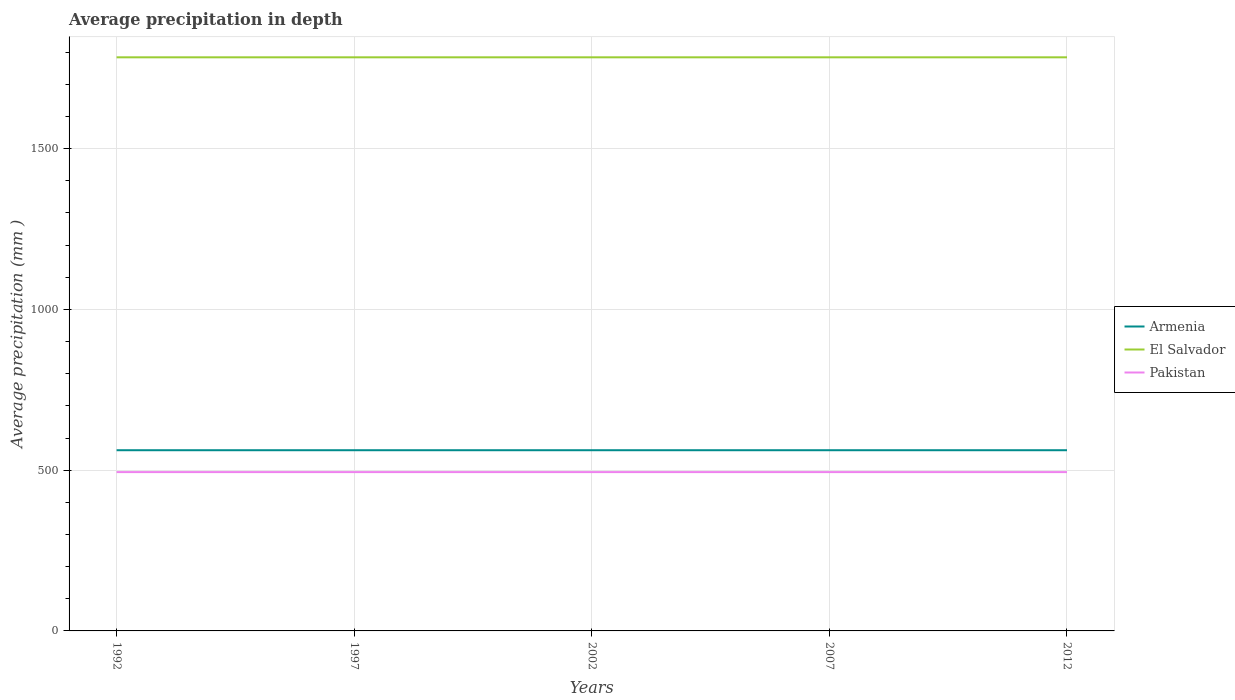How many different coloured lines are there?
Offer a very short reply. 3. Is the number of lines equal to the number of legend labels?
Offer a very short reply. Yes. Across all years, what is the maximum average precipitation in Armenia?
Offer a terse response. 562. In which year was the average precipitation in Pakistan maximum?
Keep it short and to the point. 1992. What is the total average precipitation in Pakistan in the graph?
Make the answer very short. 0. What is the difference between the highest and the second highest average precipitation in Armenia?
Your response must be concise. 0. What is the difference between the highest and the lowest average precipitation in Pakistan?
Offer a very short reply. 0. How many years are there in the graph?
Make the answer very short. 5. Are the values on the major ticks of Y-axis written in scientific E-notation?
Give a very brief answer. No. Does the graph contain any zero values?
Keep it short and to the point. No. What is the title of the graph?
Provide a succinct answer. Average precipitation in depth. Does "Guyana" appear as one of the legend labels in the graph?
Give a very brief answer. No. What is the label or title of the Y-axis?
Offer a very short reply. Average precipitation (mm ). What is the Average precipitation (mm ) in Armenia in 1992?
Your answer should be compact. 562. What is the Average precipitation (mm ) of El Salvador in 1992?
Ensure brevity in your answer.  1784. What is the Average precipitation (mm ) in Pakistan in 1992?
Provide a succinct answer. 494. What is the Average precipitation (mm ) of Armenia in 1997?
Keep it short and to the point. 562. What is the Average precipitation (mm ) in El Salvador in 1997?
Ensure brevity in your answer.  1784. What is the Average precipitation (mm ) in Pakistan in 1997?
Your answer should be compact. 494. What is the Average precipitation (mm ) of Armenia in 2002?
Ensure brevity in your answer.  562. What is the Average precipitation (mm ) of El Salvador in 2002?
Offer a very short reply. 1784. What is the Average precipitation (mm ) in Pakistan in 2002?
Provide a succinct answer. 494. What is the Average precipitation (mm ) of Armenia in 2007?
Provide a short and direct response. 562. What is the Average precipitation (mm ) of El Salvador in 2007?
Give a very brief answer. 1784. What is the Average precipitation (mm ) of Pakistan in 2007?
Make the answer very short. 494. What is the Average precipitation (mm ) of Armenia in 2012?
Provide a short and direct response. 562. What is the Average precipitation (mm ) in El Salvador in 2012?
Your answer should be very brief. 1784. What is the Average precipitation (mm ) of Pakistan in 2012?
Make the answer very short. 494. Across all years, what is the maximum Average precipitation (mm ) of Armenia?
Give a very brief answer. 562. Across all years, what is the maximum Average precipitation (mm ) of El Salvador?
Give a very brief answer. 1784. Across all years, what is the maximum Average precipitation (mm ) in Pakistan?
Provide a short and direct response. 494. Across all years, what is the minimum Average precipitation (mm ) in Armenia?
Offer a terse response. 562. Across all years, what is the minimum Average precipitation (mm ) in El Salvador?
Make the answer very short. 1784. Across all years, what is the minimum Average precipitation (mm ) in Pakistan?
Offer a terse response. 494. What is the total Average precipitation (mm ) in Armenia in the graph?
Make the answer very short. 2810. What is the total Average precipitation (mm ) in El Salvador in the graph?
Ensure brevity in your answer.  8920. What is the total Average precipitation (mm ) of Pakistan in the graph?
Provide a succinct answer. 2470. What is the difference between the Average precipitation (mm ) of El Salvador in 1992 and that in 1997?
Provide a succinct answer. 0. What is the difference between the Average precipitation (mm ) in Pakistan in 1992 and that in 1997?
Offer a very short reply. 0. What is the difference between the Average precipitation (mm ) of Armenia in 1992 and that in 2002?
Give a very brief answer. 0. What is the difference between the Average precipitation (mm ) in El Salvador in 1992 and that in 2002?
Your answer should be very brief. 0. What is the difference between the Average precipitation (mm ) of Pakistan in 1992 and that in 2002?
Give a very brief answer. 0. What is the difference between the Average precipitation (mm ) of Armenia in 1992 and that in 2007?
Your response must be concise. 0. What is the difference between the Average precipitation (mm ) in Armenia in 1997 and that in 2002?
Offer a terse response. 0. What is the difference between the Average precipitation (mm ) of El Salvador in 1997 and that in 2002?
Your answer should be very brief. 0. What is the difference between the Average precipitation (mm ) in Pakistan in 1997 and that in 2002?
Offer a very short reply. 0. What is the difference between the Average precipitation (mm ) of Pakistan in 1997 and that in 2007?
Keep it short and to the point. 0. What is the difference between the Average precipitation (mm ) of Pakistan in 1997 and that in 2012?
Your answer should be compact. 0. What is the difference between the Average precipitation (mm ) of El Salvador in 2002 and that in 2007?
Offer a very short reply. 0. What is the difference between the Average precipitation (mm ) of El Salvador in 2002 and that in 2012?
Your answer should be compact. 0. What is the difference between the Average precipitation (mm ) in Armenia in 1992 and the Average precipitation (mm ) in El Salvador in 1997?
Your answer should be compact. -1222. What is the difference between the Average precipitation (mm ) in El Salvador in 1992 and the Average precipitation (mm ) in Pakistan in 1997?
Give a very brief answer. 1290. What is the difference between the Average precipitation (mm ) in Armenia in 1992 and the Average precipitation (mm ) in El Salvador in 2002?
Offer a very short reply. -1222. What is the difference between the Average precipitation (mm ) in El Salvador in 1992 and the Average precipitation (mm ) in Pakistan in 2002?
Offer a very short reply. 1290. What is the difference between the Average precipitation (mm ) of Armenia in 1992 and the Average precipitation (mm ) of El Salvador in 2007?
Provide a short and direct response. -1222. What is the difference between the Average precipitation (mm ) in El Salvador in 1992 and the Average precipitation (mm ) in Pakistan in 2007?
Keep it short and to the point. 1290. What is the difference between the Average precipitation (mm ) in Armenia in 1992 and the Average precipitation (mm ) in El Salvador in 2012?
Give a very brief answer. -1222. What is the difference between the Average precipitation (mm ) of El Salvador in 1992 and the Average precipitation (mm ) of Pakistan in 2012?
Your answer should be very brief. 1290. What is the difference between the Average precipitation (mm ) of Armenia in 1997 and the Average precipitation (mm ) of El Salvador in 2002?
Give a very brief answer. -1222. What is the difference between the Average precipitation (mm ) in El Salvador in 1997 and the Average precipitation (mm ) in Pakistan in 2002?
Offer a terse response. 1290. What is the difference between the Average precipitation (mm ) in Armenia in 1997 and the Average precipitation (mm ) in El Salvador in 2007?
Your answer should be compact. -1222. What is the difference between the Average precipitation (mm ) of El Salvador in 1997 and the Average precipitation (mm ) of Pakistan in 2007?
Your answer should be compact. 1290. What is the difference between the Average precipitation (mm ) in Armenia in 1997 and the Average precipitation (mm ) in El Salvador in 2012?
Your response must be concise. -1222. What is the difference between the Average precipitation (mm ) of El Salvador in 1997 and the Average precipitation (mm ) of Pakistan in 2012?
Provide a short and direct response. 1290. What is the difference between the Average precipitation (mm ) in Armenia in 2002 and the Average precipitation (mm ) in El Salvador in 2007?
Provide a succinct answer. -1222. What is the difference between the Average precipitation (mm ) of Armenia in 2002 and the Average precipitation (mm ) of Pakistan in 2007?
Provide a succinct answer. 68. What is the difference between the Average precipitation (mm ) of El Salvador in 2002 and the Average precipitation (mm ) of Pakistan in 2007?
Keep it short and to the point. 1290. What is the difference between the Average precipitation (mm ) in Armenia in 2002 and the Average precipitation (mm ) in El Salvador in 2012?
Your answer should be very brief. -1222. What is the difference between the Average precipitation (mm ) in El Salvador in 2002 and the Average precipitation (mm ) in Pakistan in 2012?
Make the answer very short. 1290. What is the difference between the Average precipitation (mm ) in Armenia in 2007 and the Average precipitation (mm ) in El Salvador in 2012?
Your response must be concise. -1222. What is the difference between the Average precipitation (mm ) of El Salvador in 2007 and the Average precipitation (mm ) of Pakistan in 2012?
Offer a terse response. 1290. What is the average Average precipitation (mm ) in Armenia per year?
Keep it short and to the point. 562. What is the average Average precipitation (mm ) in El Salvador per year?
Your answer should be very brief. 1784. What is the average Average precipitation (mm ) in Pakistan per year?
Offer a terse response. 494. In the year 1992, what is the difference between the Average precipitation (mm ) in Armenia and Average precipitation (mm ) in El Salvador?
Give a very brief answer. -1222. In the year 1992, what is the difference between the Average precipitation (mm ) of Armenia and Average precipitation (mm ) of Pakistan?
Provide a succinct answer. 68. In the year 1992, what is the difference between the Average precipitation (mm ) in El Salvador and Average precipitation (mm ) in Pakistan?
Provide a succinct answer. 1290. In the year 1997, what is the difference between the Average precipitation (mm ) in Armenia and Average precipitation (mm ) in El Salvador?
Make the answer very short. -1222. In the year 1997, what is the difference between the Average precipitation (mm ) in El Salvador and Average precipitation (mm ) in Pakistan?
Offer a terse response. 1290. In the year 2002, what is the difference between the Average precipitation (mm ) in Armenia and Average precipitation (mm ) in El Salvador?
Ensure brevity in your answer.  -1222. In the year 2002, what is the difference between the Average precipitation (mm ) of El Salvador and Average precipitation (mm ) of Pakistan?
Provide a succinct answer. 1290. In the year 2007, what is the difference between the Average precipitation (mm ) in Armenia and Average precipitation (mm ) in El Salvador?
Provide a short and direct response. -1222. In the year 2007, what is the difference between the Average precipitation (mm ) of El Salvador and Average precipitation (mm ) of Pakistan?
Keep it short and to the point. 1290. In the year 2012, what is the difference between the Average precipitation (mm ) of Armenia and Average precipitation (mm ) of El Salvador?
Your answer should be very brief. -1222. In the year 2012, what is the difference between the Average precipitation (mm ) of El Salvador and Average precipitation (mm ) of Pakistan?
Provide a short and direct response. 1290. What is the ratio of the Average precipitation (mm ) in Armenia in 1992 to that in 1997?
Offer a terse response. 1. What is the ratio of the Average precipitation (mm ) in Armenia in 1992 to that in 2002?
Keep it short and to the point. 1. What is the ratio of the Average precipitation (mm ) in Pakistan in 1992 to that in 2002?
Provide a succinct answer. 1. What is the ratio of the Average precipitation (mm ) in Armenia in 1992 to that in 2007?
Your response must be concise. 1. What is the ratio of the Average precipitation (mm ) in Armenia in 1992 to that in 2012?
Give a very brief answer. 1. What is the ratio of the Average precipitation (mm ) in El Salvador in 1992 to that in 2012?
Your answer should be compact. 1. What is the ratio of the Average precipitation (mm ) of Pakistan in 1992 to that in 2012?
Offer a terse response. 1. What is the ratio of the Average precipitation (mm ) of Armenia in 1997 to that in 2002?
Provide a short and direct response. 1. What is the ratio of the Average precipitation (mm ) of El Salvador in 1997 to that in 2002?
Your answer should be very brief. 1. What is the ratio of the Average precipitation (mm ) of El Salvador in 1997 to that in 2012?
Offer a terse response. 1. What is the ratio of the Average precipitation (mm ) of Pakistan in 2002 to that in 2007?
Ensure brevity in your answer.  1. What is the ratio of the Average precipitation (mm ) in El Salvador in 2002 to that in 2012?
Provide a succinct answer. 1. What is the ratio of the Average precipitation (mm ) in Pakistan in 2002 to that in 2012?
Your answer should be compact. 1. What is the ratio of the Average precipitation (mm ) of Pakistan in 2007 to that in 2012?
Offer a very short reply. 1. What is the difference between the highest and the second highest Average precipitation (mm ) in Armenia?
Make the answer very short. 0. What is the difference between the highest and the lowest Average precipitation (mm ) of Armenia?
Make the answer very short. 0. What is the difference between the highest and the lowest Average precipitation (mm ) of El Salvador?
Give a very brief answer. 0. What is the difference between the highest and the lowest Average precipitation (mm ) of Pakistan?
Offer a very short reply. 0. 